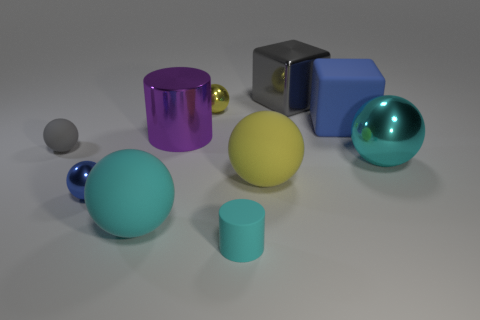Subtract all green cylinders. How many yellow spheres are left? 2 Subtract all large cyan shiny spheres. How many spheres are left? 5 Subtract all blue spheres. How many spheres are left? 5 Subtract 3 spheres. How many spheres are left? 3 Subtract all cylinders. How many objects are left? 8 Add 9 gray rubber things. How many gray rubber things exist? 10 Subtract 0 yellow cylinders. How many objects are left? 10 Subtract all yellow spheres. Subtract all blue blocks. How many spheres are left? 4 Subtract all yellow spheres. Subtract all small blue shiny balls. How many objects are left? 7 Add 6 cyan spheres. How many cyan spheres are left? 8 